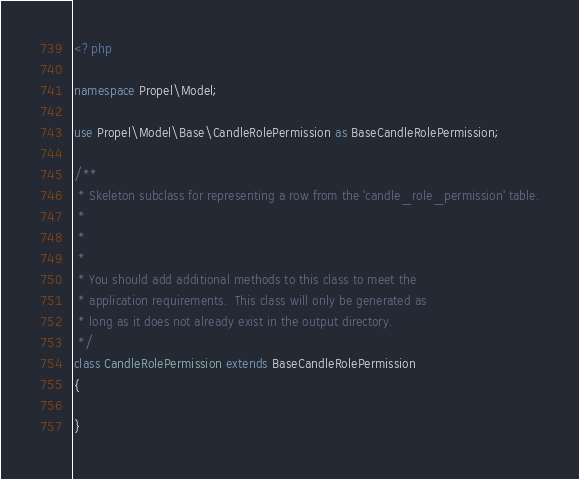Convert code to text. <code><loc_0><loc_0><loc_500><loc_500><_PHP_><?php

namespace Propel\Model;

use Propel\Model\Base\CandleRolePermission as BaseCandleRolePermission;

/**
 * Skeleton subclass for representing a row from the 'candle_role_permission' table.
 *
 *
 *
 * You should add additional methods to this class to meet the
 * application requirements.  This class will only be generated as
 * long as it does not already exist in the output directory.
 */
class CandleRolePermission extends BaseCandleRolePermission
{

}
</code> 